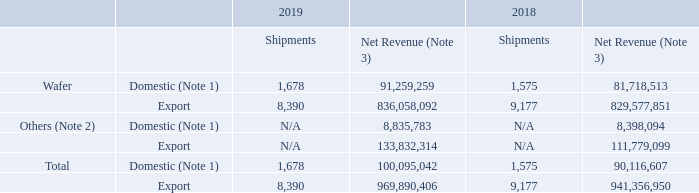5.1.3 Consolidated Shipments and Net Revenue in 2019 and 2018
Unit: Shipments (thousand 12-inch equivalent wafers) / Net Revenue (NT$ thousands)
Note 1: Domestic means sales to Taiwan. Note 2: Others mainly include revenue associated with packaging and testing services, mask making, design services, and royalties.
Note 3: Commencing in 2018, the Company began to break down the net revenue by product based on a new method which associates most estimated sales returns and allowances with individual sales transactions, as opposed to the previous method which allocated sales returns and allowances based on the aforementioned gross revenue. The Company believes the new method provides a more relevant breakdown than the previous one.
What is meant by Domestic? Sales to taiwan. What is included in others? Revenue associated with packaging and testing services, mask making, design services, and royalties. How did the the Company began to break down the net revenue by product since 2018? Based on a new method which associates most estimated sales returns and allowances with individual sales transactions, as opposed to the previous method which allocated sales returns and allowances based on the aforementioned gross revenue. What is the change in Wafer Domestic Shipments between 2018 and 2019?
Answer scale should be: thousand. 1,678-1,575
Answer: 103. What is the change in Wafer Domestic Net Revenue between 2018 and 2019?
Answer scale should be: thousand. 91,259,259-81,718,513
Answer: 9540746. What is the change in Others Domestic Net Revenue between 2018 and 2019?
Answer scale should be: thousand. 8,835,783-8,398,094
Answer: 437689. 